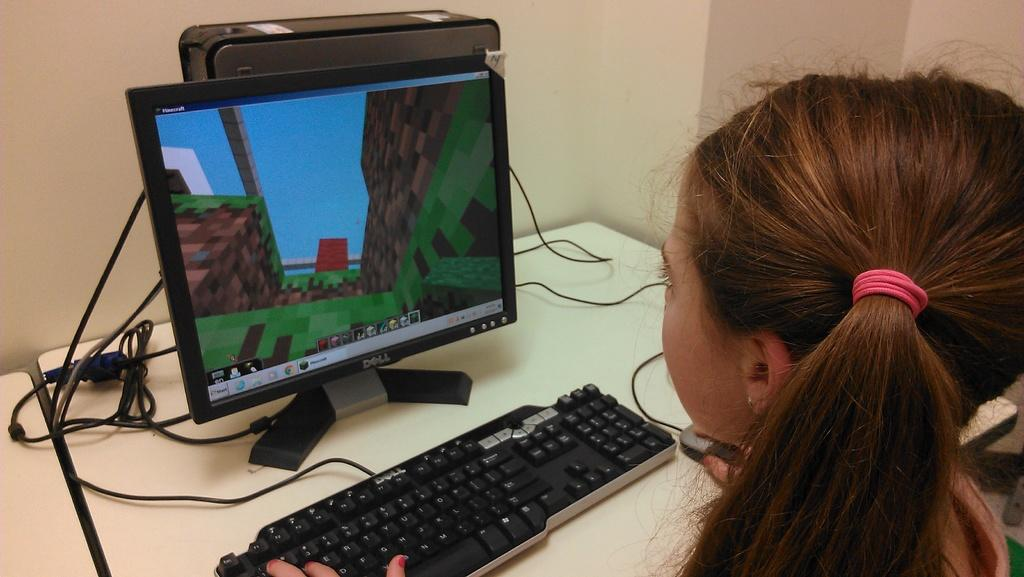<image>
Summarize the visual content of the image. A girl working on a Dell computer and playing a pixilated video game. 